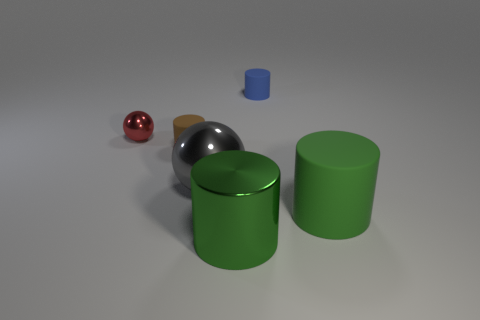Are there any brown cylinders that are to the right of the large green cylinder in front of the matte cylinder in front of the large metallic sphere?
Offer a very short reply. No. Are the tiny brown cylinder and the tiny cylinder that is behind the brown matte cylinder made of the same material?
Your response must be concise. Yes. There is a cylinder that is right of the matte cylinder that is behind the small red ball; what color is it?
Offer a terse response. Green. Is there another tiny sphere of the same color as the tiny shiny sphere?
Your answer should be compact. No. How big is the shiny object that is to the left of the large gray metallic thing that is to the left of the shiny object on the right side of the gray ball?
Provide a short and direct response. Small. Does the brown object have the same shape as the metal thing behind the large sphere?
Ensure brevity in your answer.  No. How many other objects are there of the same size as the gray metal object?
Your response must be concise. 2. How big is the matte thing in front of the large shiny sphere?
Your answer should be very brief. Large. What number of other big spheres have the same material as the big ball?
Offer a terse response. 0. Does the shiny object in front of the large gray sphere have the same shape as the brown rubber object?
Offer a terse response. Yes. 